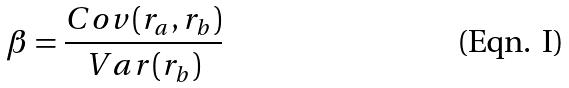Convert formula to latex. <formula><loc_0><loc_0><loc_500><loc_500>\beta = \frac { C o v ( r _ { a } , r _ { b } ) } { V a r ( r _ { b } ) }</formula> 